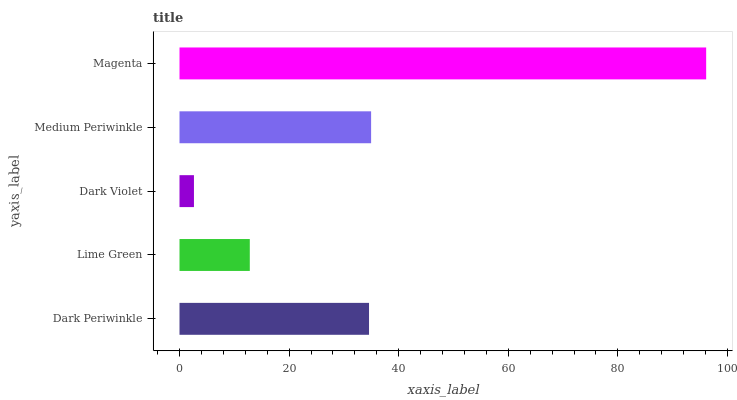Is Dark Violet the minimum?
Answer yes or no. Yes. Is Magenta the maximum?
Answer yes or no. Yes. Is Lime Green the minimum?
Answer yes or no. No. Is Lime Green the maximum?
Answer yes or no. No. Is Dark Periwinkle greater than Lime Green?
Answer yes or no. Yes. Is Lime Green less than Dark Periwinkle?
Answer yes or no. Yes. Is Lime Green greater than Dark Periwinkle?
Answer yes or no. No. Is Dark Periwinkle less than Lime Green?
Answer yes or no. No. Is Dark Periwinkle the high median?
Answer yes or no. Yes. Is Dark Periwinkle the low median?
Answer yes or no. Yes. Is Lime Green the high median?
Answer yes or no. No. Is Magenta the low median?
Answer yes or no. No. 